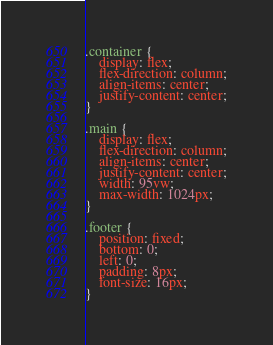<code> <loc_0><loc_0><loc_500><loc_500><_CSS_>.container {
    display: flex;
    flex-direction: column;
    align-items: center;
    justify-content: center;
}

.main {
    display: flex;
    flex-direction: column;
    align-items: center;
    justify-content: center;
    width: 95vw;
    max-width: 1024px;
}

.footer {
    position: fixed;
    bottom: 0;
    left: 0;
    padding: 8px;
    font-size: 16px;
}
</code> 